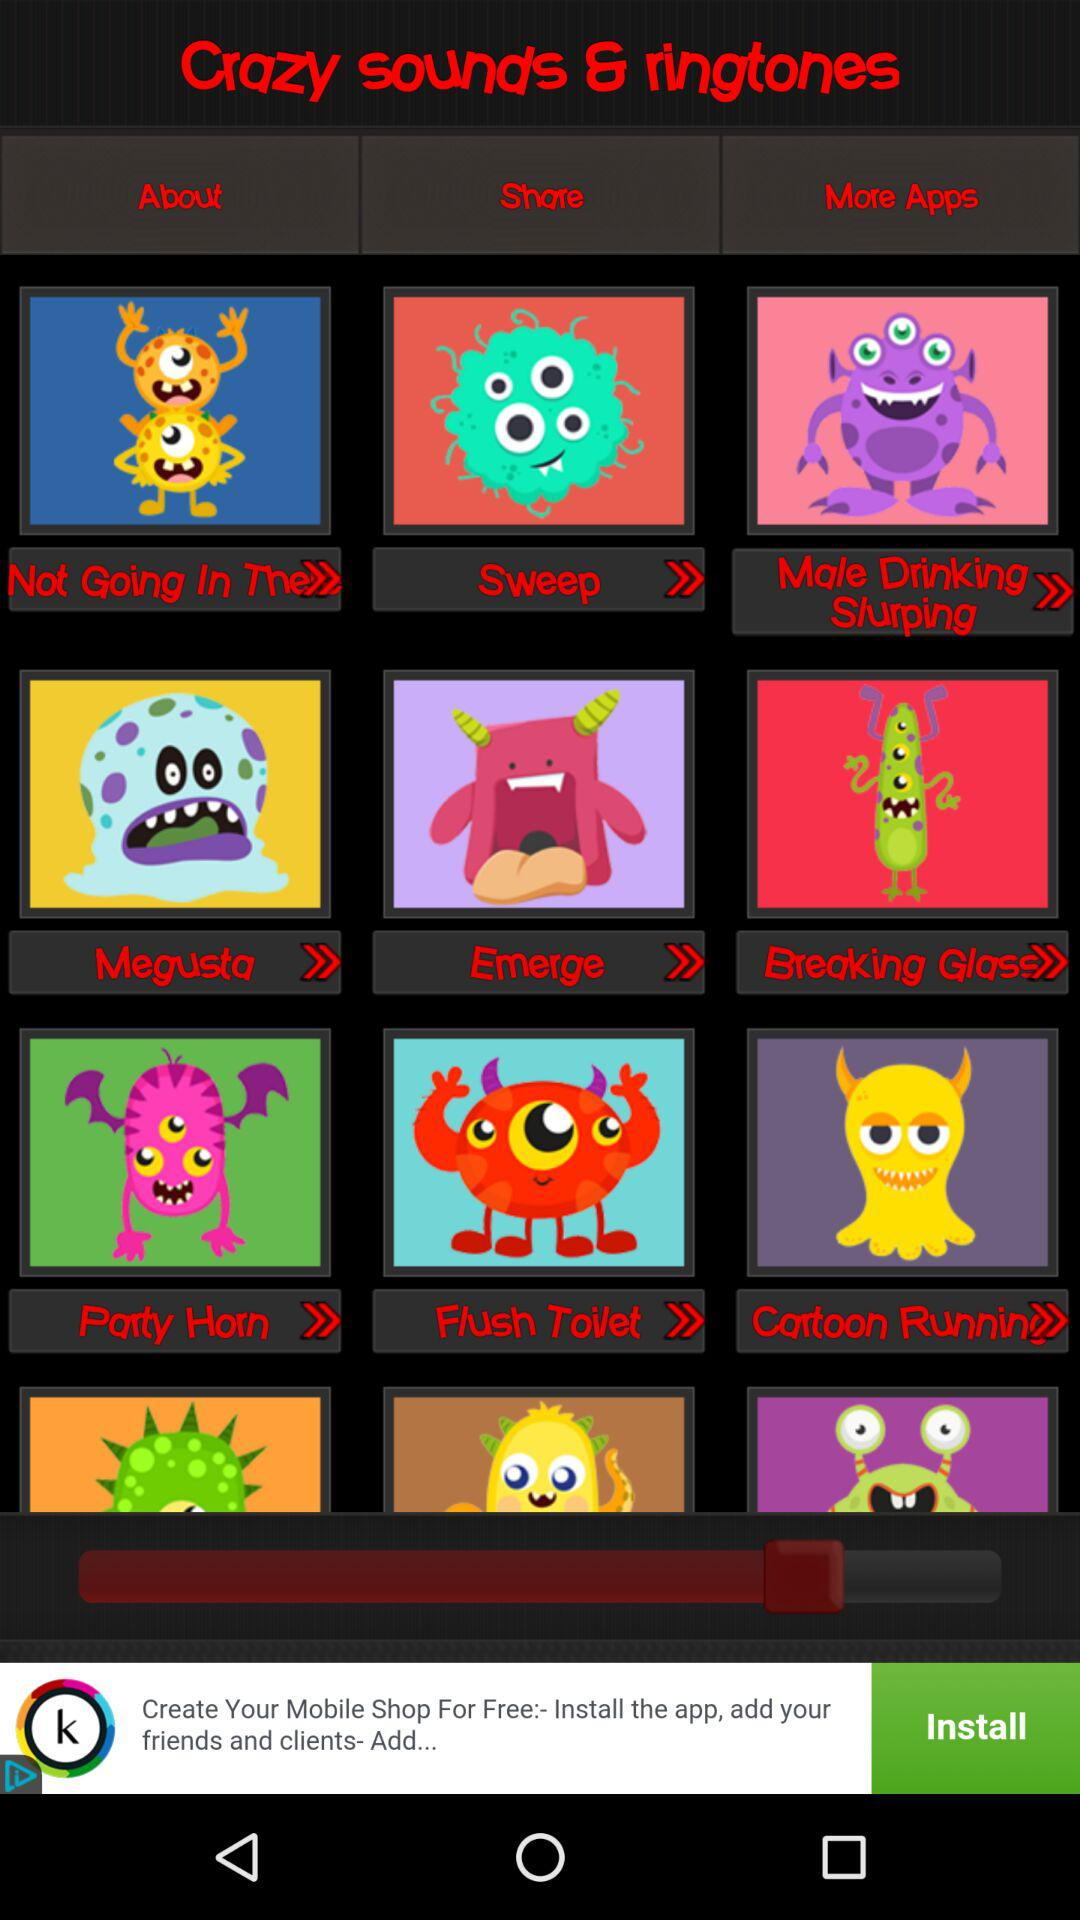What is the name of the application? The name of the application is "Crazy sounds & ringtones". 